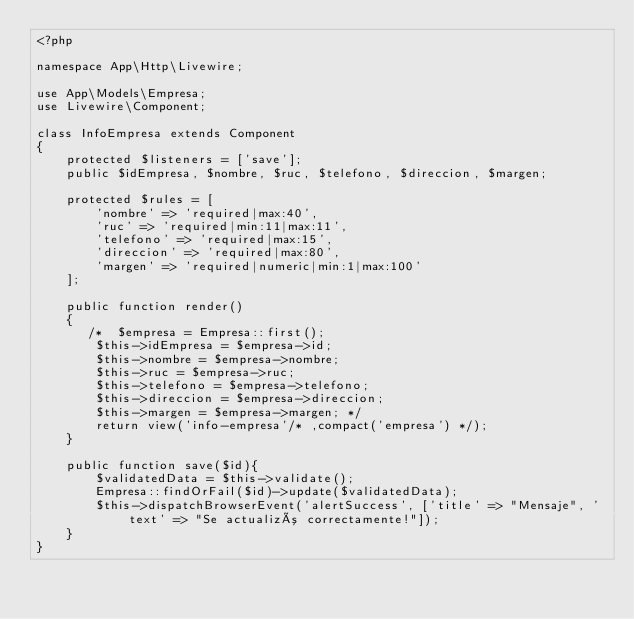Convert code to text. <code><loc_0><loc_0><loc_500><loc_500><_PHP_><?php

namespace App\Http\Livewire;

use App\Models\Empresa;
use Livewire\Component;

class InfoEmpresa extends Component
{
    protected $listeners = ['save'];
    public $idEmpresa, $nombre, $ruc, $telefono, $direccion, $margen;

    protected $rules = [
        'nombre' => 'required|max:40',
        'ruc' => 'required|min:11|max:11',
        'telefono' => 'required|max:15',
        'direccion' => 'required|max:80',
        'margen' => 'required|numeric|min:1|max:100'
    ];

    public function render()
    {
       /*  $empresa = Empresa::first();
        $this->idEmpresa = $empresa->id;
        $this->nombre = $empresa->nombre;
        $this->ruc = $empresa->ruc;
        $this->telefono = $empresa->telefono;
        $this->direccion = $empresa->direccion;
        $this->margen = $empresa->margen; */
        return view('info-empresa'/* ,compact('empresa') */);
    }

    public function save($id){
        $validatedData = $this->validate();
        Empresa::findOrFail($id)->update($validatedData);
        $this->dispatchBrowserEvent('alertSuccess', ['title' => "Mensaje", 'text' => "Se actualizó correctamente!"]);
    }
}
</code> 